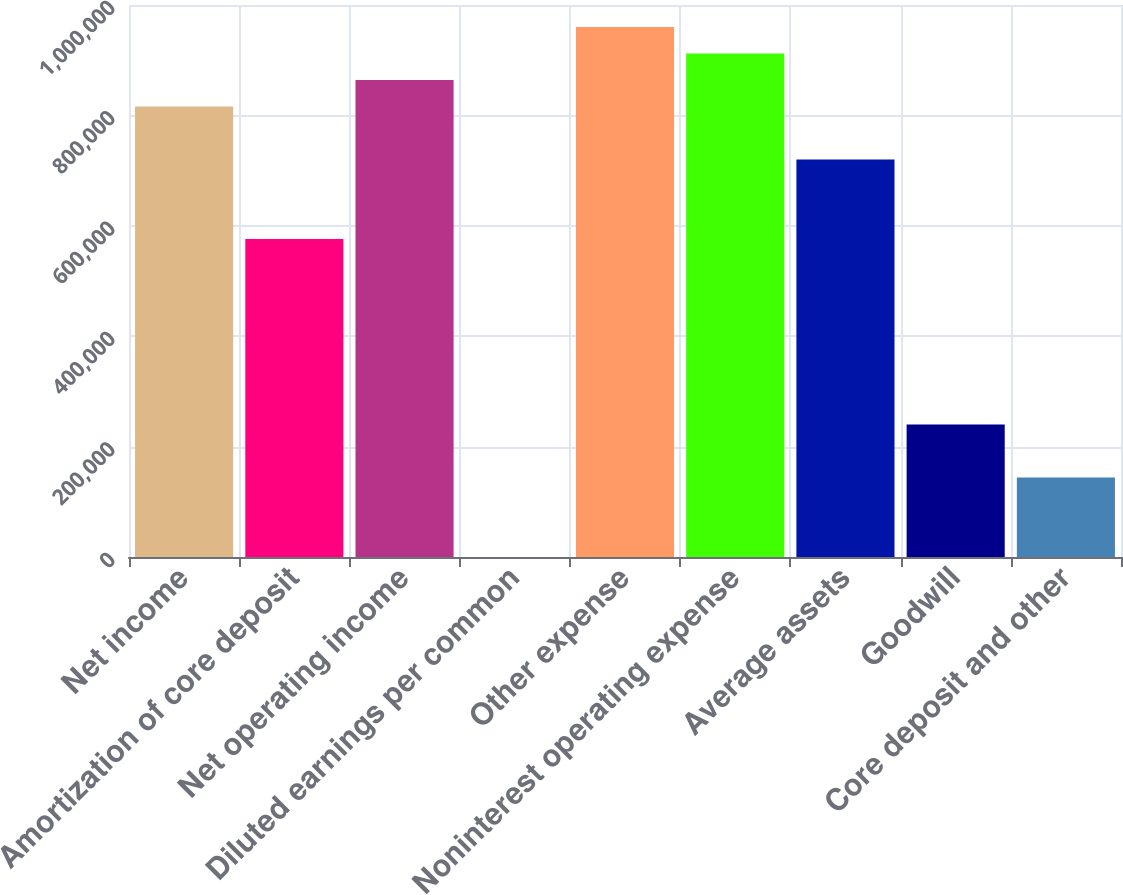Convert chart. <chart><loc_0><loc_0><loc_500><loc_500><bar_chart><fcel>Net income<fcel>Amortization of core deposit<fcel>Net operating income<fcel>Diluted earnings per common<fcel>Other expense<fcel>Noninterest operating expense<fcel>Average assets<fcel>Goodwill<fcel>Core deposit and other<nl><fcel>816225<fcel>576159<fcel>864238<fcel>1.48<fcel>960264<fcel>912251<fcel>720199<fcel>240067<fcel>144041<nl></chart> 